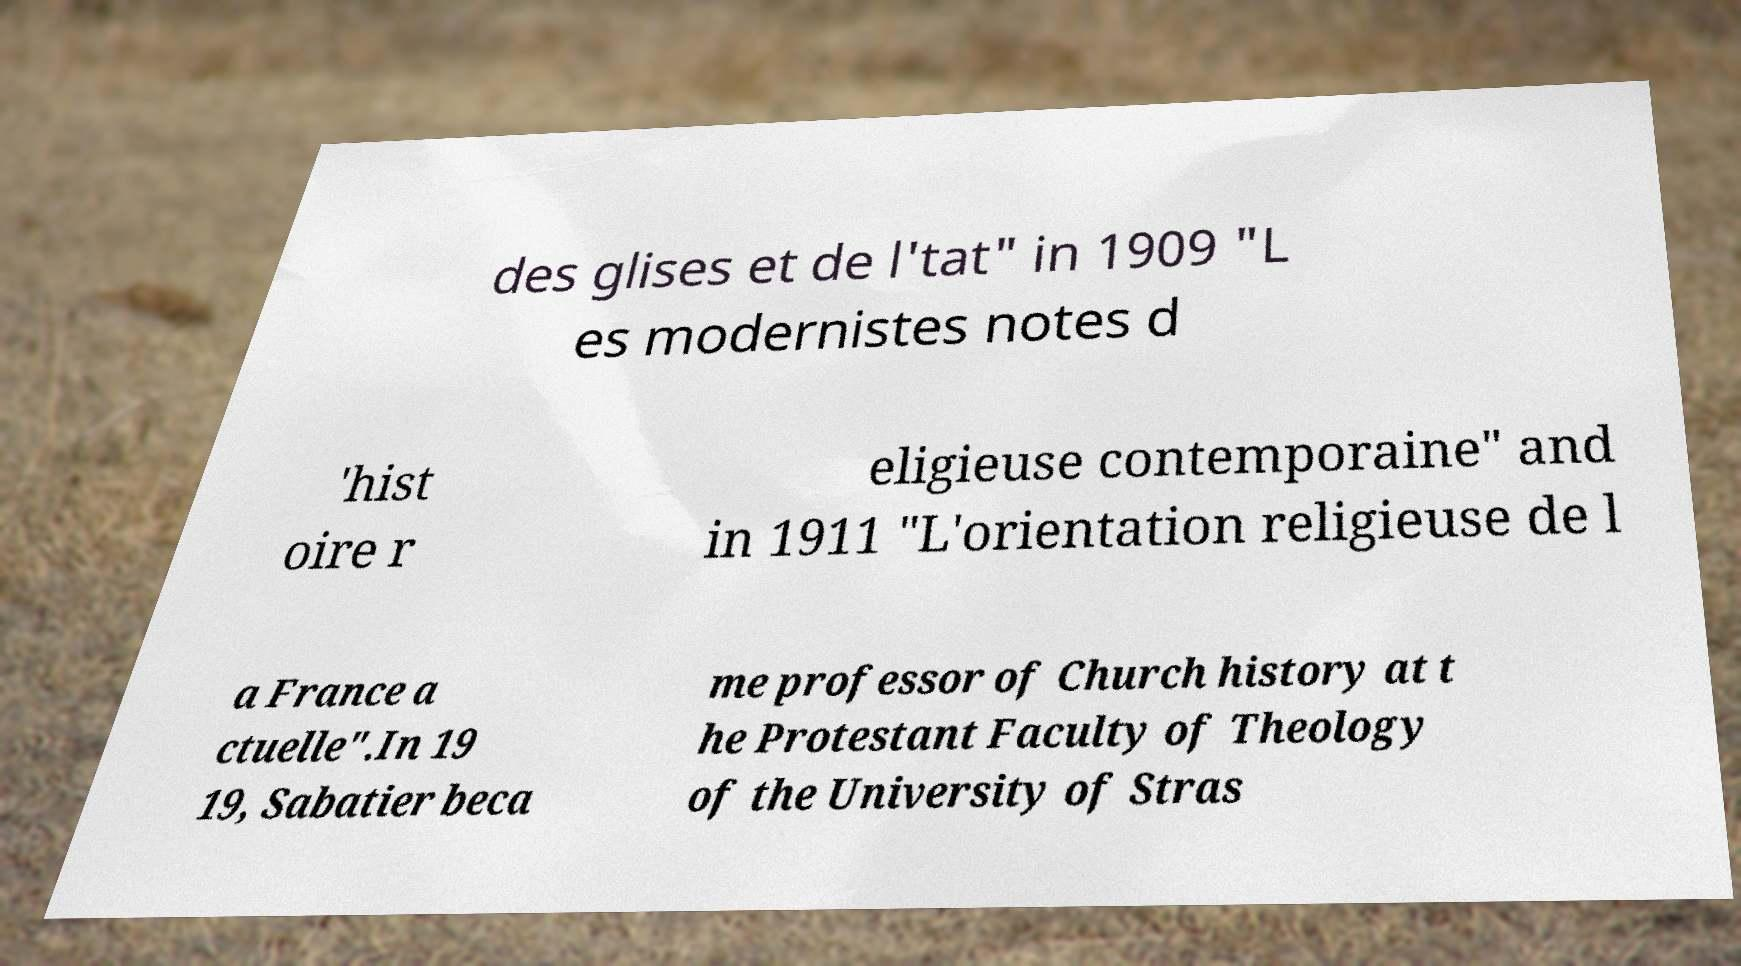Can you accurately transcribe the text from the provided image for me? des glises et de l'tat" in 1909 "L es modernistes notes d 'hist oire r eligieuse contemporaine" and in 1911 "L'orientation religieuse de l a France a ctuelle".In 19 19, Sabatier beca me professor of Church history at t he Protestant Faculty of Theology of the University of Stras 